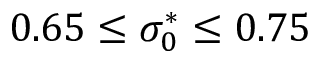<formula> <loc_0><loc_0><loc_500><loc_500>0 . 6 5 \leq \sigma _ { 0 } ^ { * } \leq 0 . 7 5</formula> 